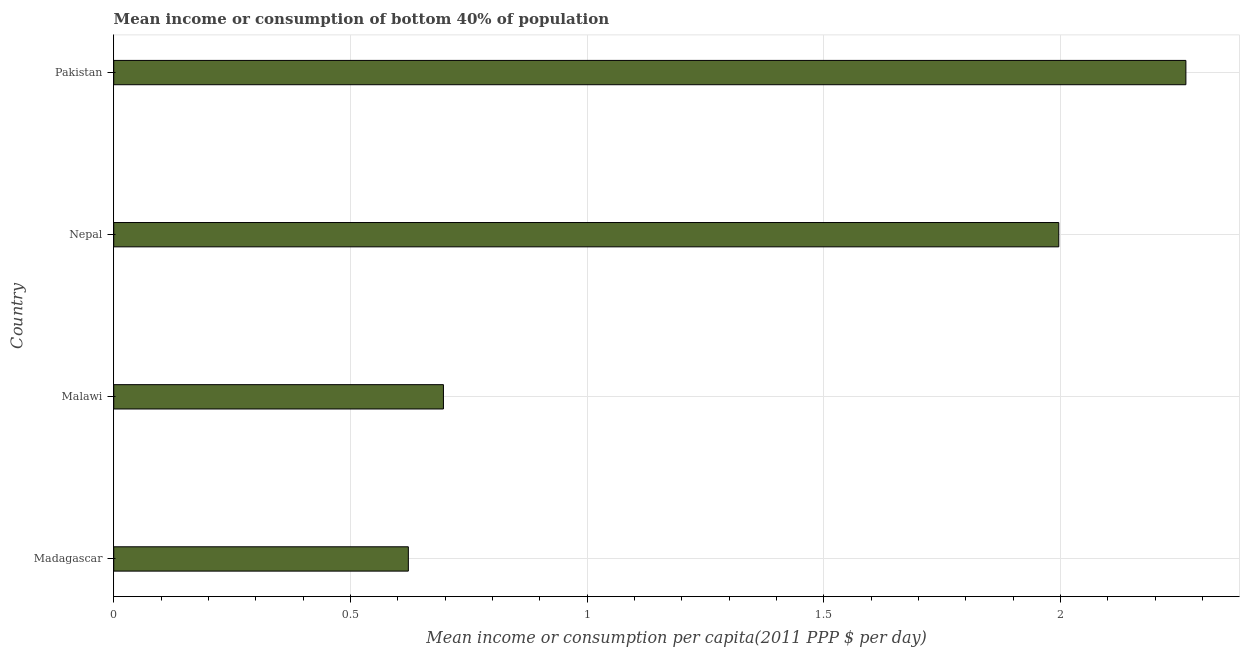Does the graph contain any zero values?
Provide a succinct answer. No. What is the title of the graph?
Offer a very short reply. Mean income or consumption of bottom 40% of population. What is the label or title of the X-axis?
Offer a very short reply. Mean income or consumption per capita(2011 PPP $ per day). What is the label or title of the Y-axis?
Make the answer very short. Country. What is the mean income or consumption in Pakistan?
Keep it short and to the point. 2.27. Across all countries, what is the maximum mean income or consumption?
Give a very brief answer. 2.27. Across all countries, what is the minimum mean income or consumption?
Make the answer very short. 0.62. In which country was the mean income or consumption minimum?
Give a very brief answer. Madagascar. What is the sum of the mean income or consumption?
Offer a terse response. 5.58. What is the difference between the mean income or consumption in Malawi and Pakistan?
Offer a terse response. -1.57. What is the average mean income or consumption per country?
Provide a short and direct response. 1.4. What is the median mean income or consumption?
Keep it short and to the point. 1.35. In how many countries, is the mean income or consumption greater than 0.4 $?
Ensure brevity in your answer.  4. What is the ratio of the mean income or consumption in Madagascar to that in Pakistan?
Give a very brief answer. 0.28. Is the difference between the mean income or consumption in Madagascar and Nepal greater than the difference between any two countries?
Offer a terse response. No. What is the difference between the highest and the second highest mean income or consumption?
Ensure brevity in your answer.  0.27. Is the sum of the mean income or consumption in Madagascar and Malawi greater than the maximum mean income or consumption across all countries?
Ensure brevity in your answer.  No. What is the difference between the highest and the lowest mean income or consumption?
Provide a succinct answer. 1.64. In how many countries, is the mean income or consumption greater than the average mean income or consumption taken over all countries?
Keep it short and to the point. 2. How many bars are there?
Keep it short and to the point. 4. Are all the bars in the graph horizontal?
Give a very brief answer. Yes. How many countries are there in the graph?
Provide a succinct answer. 4. What is the difference between two consecutive major ticks on the X-axis?
Offer a terse response. 0.5. What is the Mean income or consumption per capita(2011 PPP $ per day) of Madagascar?
Your answer should be very brief. 0.62. What is the Mean income or consumption per capita(2011 PPP $ per day) of Malawi?
Provide a short and direct response. 0.7. What is the Mean income or consumption per capita(2011 PPP $ per day) in Nepal?
Provide a short and direct response. 2. What is the Mean income or consumption per capita(2011 PPP $ per day) in Pakistan?
Give a very brief answer. 2.27. What is the difference between the Mean income or consumption per capita(2011 PPP $ per day) in Madagascar and Malawi?
Offer a very short reply. -0.07. What is the difference between the Mean income or consumption per capita(2011 PPP $ per day) in Madagascar and Nepal?
Your answer should be compact. -1.37. What is the difference between the Mean income or consumption per capita(2011 PPP $ per day) in Madagascar and Pakistan?
Offer a terse response. -1.64. What is the difference between the Mean income or consumption per capita(2011 PPP $ per day) in Malawi and Nepal?
Offer a terse response. -1.3. What is the difference between the Mean income or consumption per capita(2011 PPP $ per day) in Malawi and Pakistan?
Your answer should be very brief. -1.57. What is the difference between the Mean income or consumption per capita(2011 PPP $ per day) in Nepal and Pakistan?
Provide a short and direct response. -0.27. What is the ratio of the Mean income or consumption per capita(2011 PPP $ per day) in Madagascar to that in Malawi?
Your response must be concise. 0.89. What is the ratio of the Mean income or consumption per capita(2011 PPP $ per day) in Madagascar to that in Nepal?
Make the answer very short. 0.31. What is the ratio of the Mean income or consumption per capita(2011 PPP $ per day) in Madagascar to that in Pakistan?
Offer a very short reply. 0.28. What is the ratio of the Mean income or consumption per capita(2011 PPP $ per day) in Malawi to that in Nepal?
Offer a very short reply. 0.35. What is the ratio of the Mean income or consumption per capita(2011 PPP $ per day) in Malawi to that in Pakistan?
Make the answer very short. 0.31. What is the ratio of the Mean income or consumption per capita(2011 PPP $ per day) in Nepal to that in Pakistan?
Make the answer very short. 0.88. 